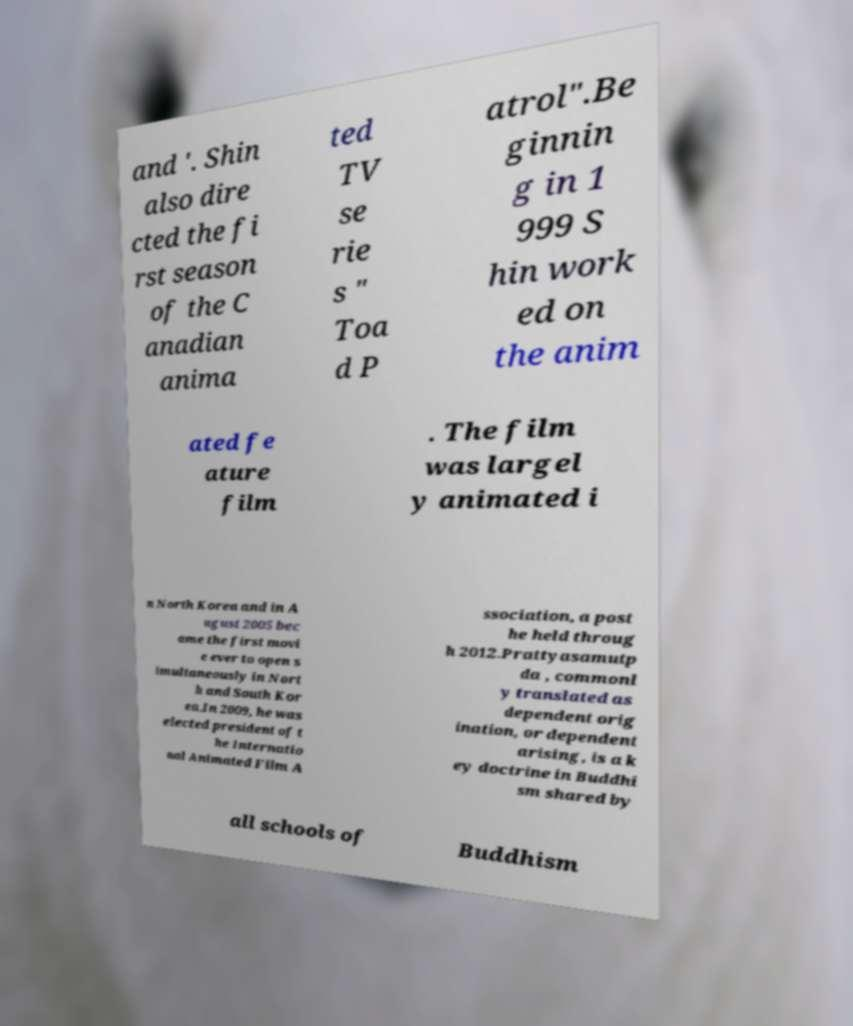Please identify and transcribe the text found in this image. and '. Shin also dire cted the fi rst season of the C anadian anima ted TV se rie s " Toa d P atrol".Be ginnin g in 1 999 S hin work ed on the anim ated fe ature film . The film was largel y animated i n North Korea and in A ugust 2005 bec ame the first movi e ever to open s imultaneously in Nort h and South Kor ea.In 2009, he was elected president of t he Internatio nal Animated Film A ssociation, a post he held throug h 2012.Prattyasamutp da , commonl y translated as dependent orig ination, or dependent arising, is a k ey doctrine in Buddhi sm shared by all schools of Buddhism 